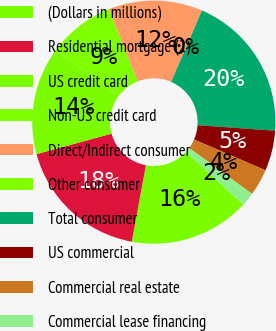Convert chart. <chart><loc_0><loc_0><loc_500><loc_500><pie_chart><fcel>(Dollars in millions)<fcel>Residential mortgage (2)<fcel>US credit card<fcel>Non-US credit card<fcel>Direct/Indirect consumer<fcel>Other consumer<fcel>Total consumer<fcel>US commercial<fcel>Commercial real estate<fcel>Commercial lease financing<nl><fcel>16.07%<fcel>17.86%<fcel>14.29%<fcel>8.93%<fcel>12.5%<fcel>0.0%<fcel>19.64%<fcel>5.36%<fcel>3.57%<fcel>1.79%<nl></chart> 